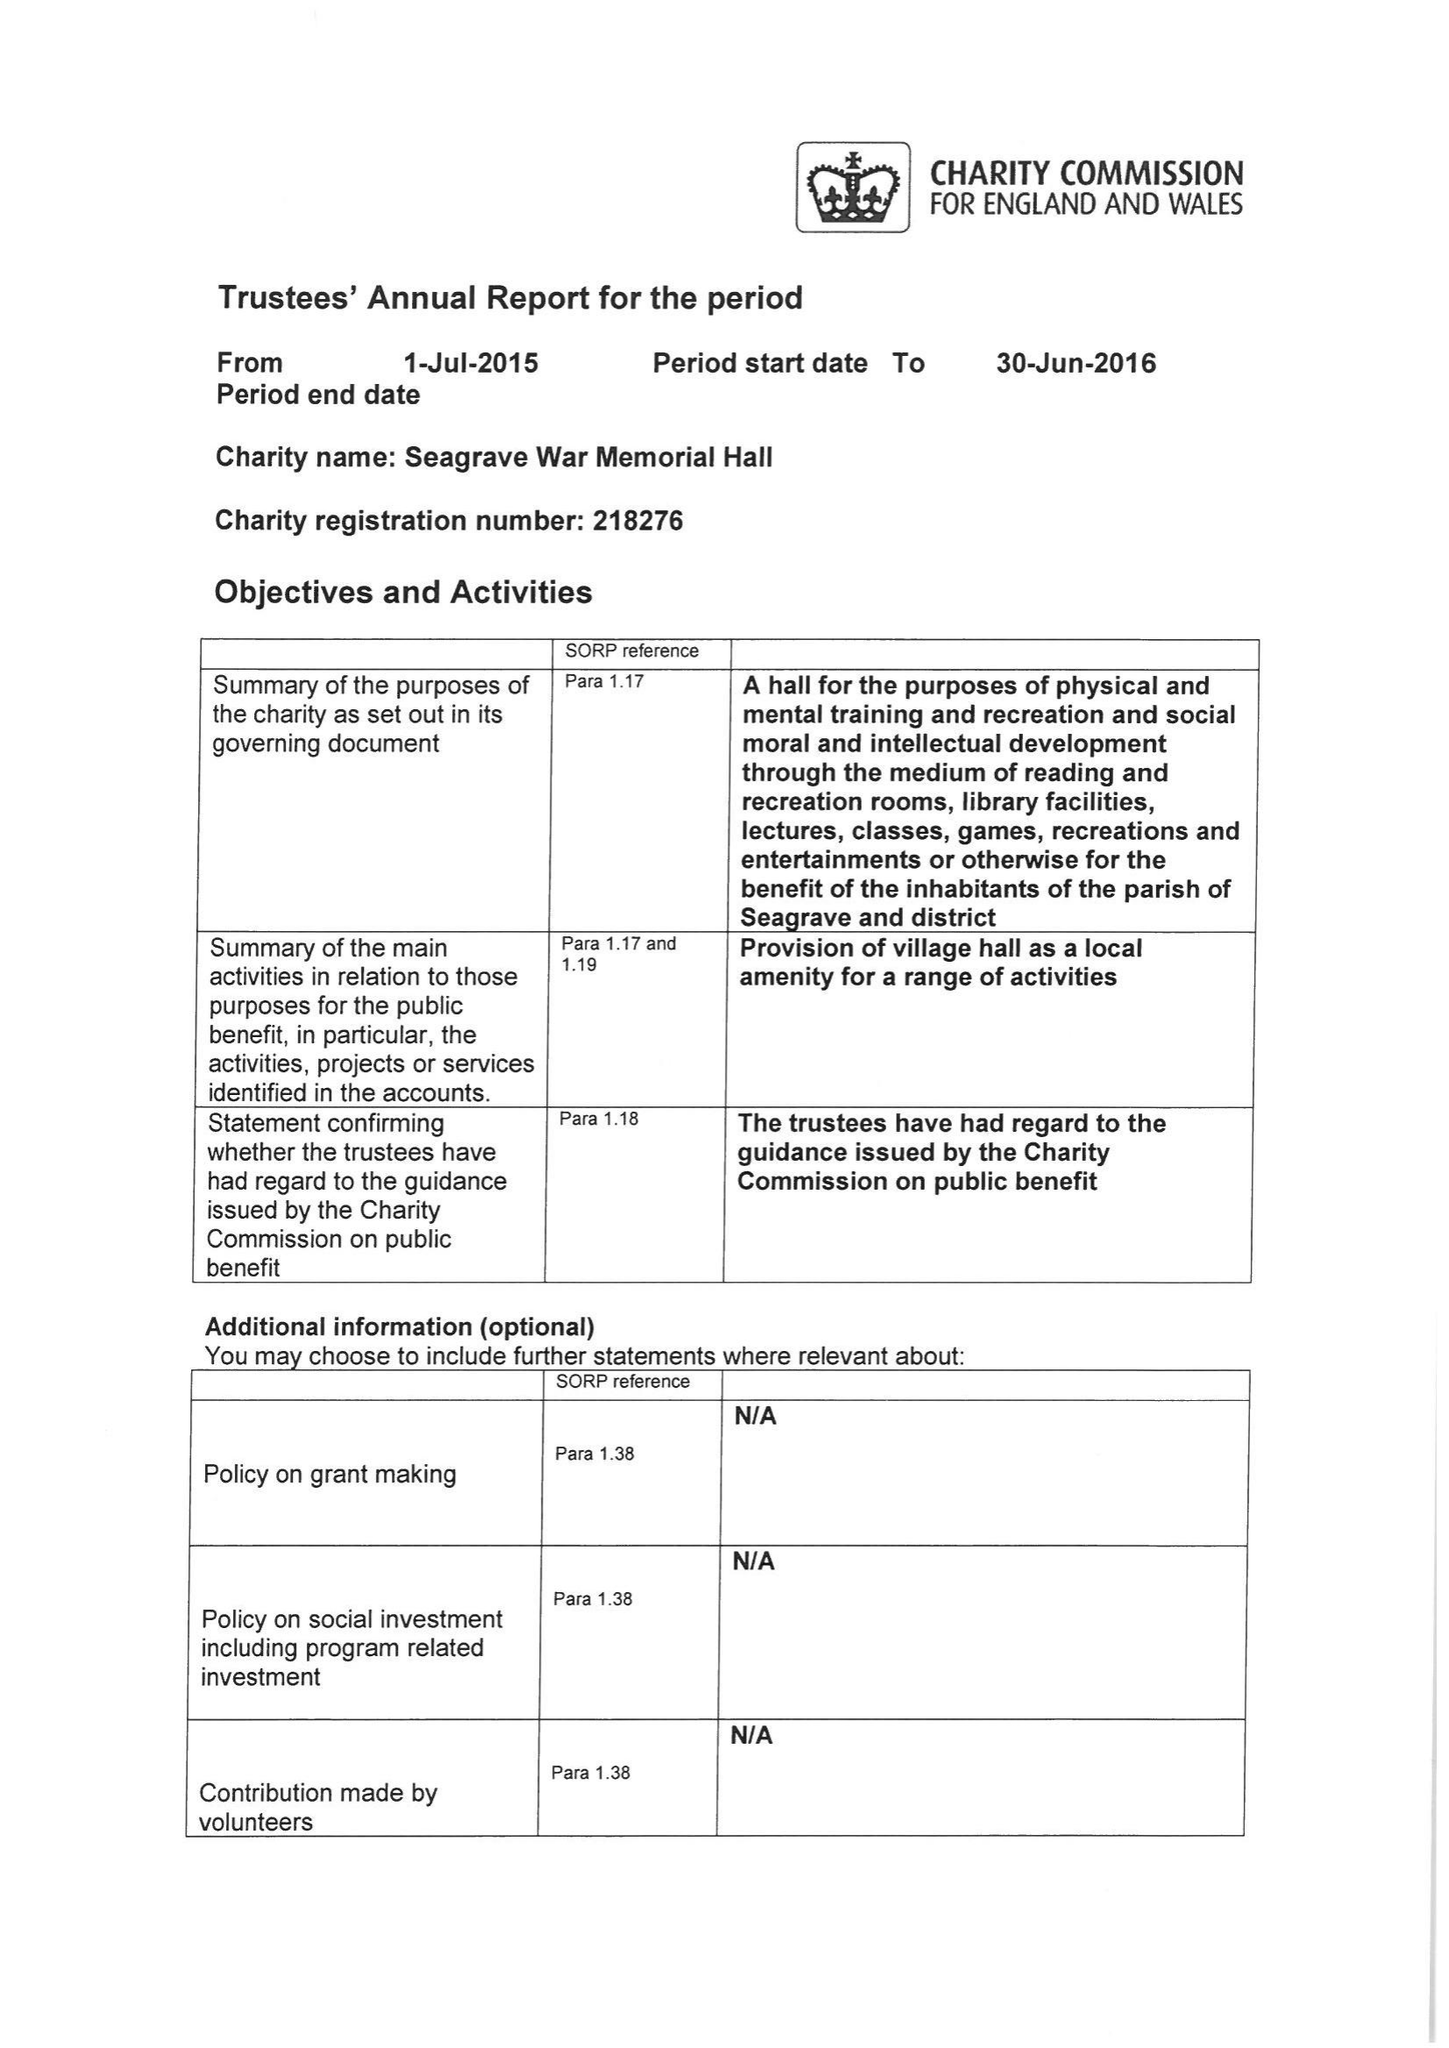What is the value for the charity_name?
Answer the question using a single word or phrase. Seagrave War Memorial Hall 